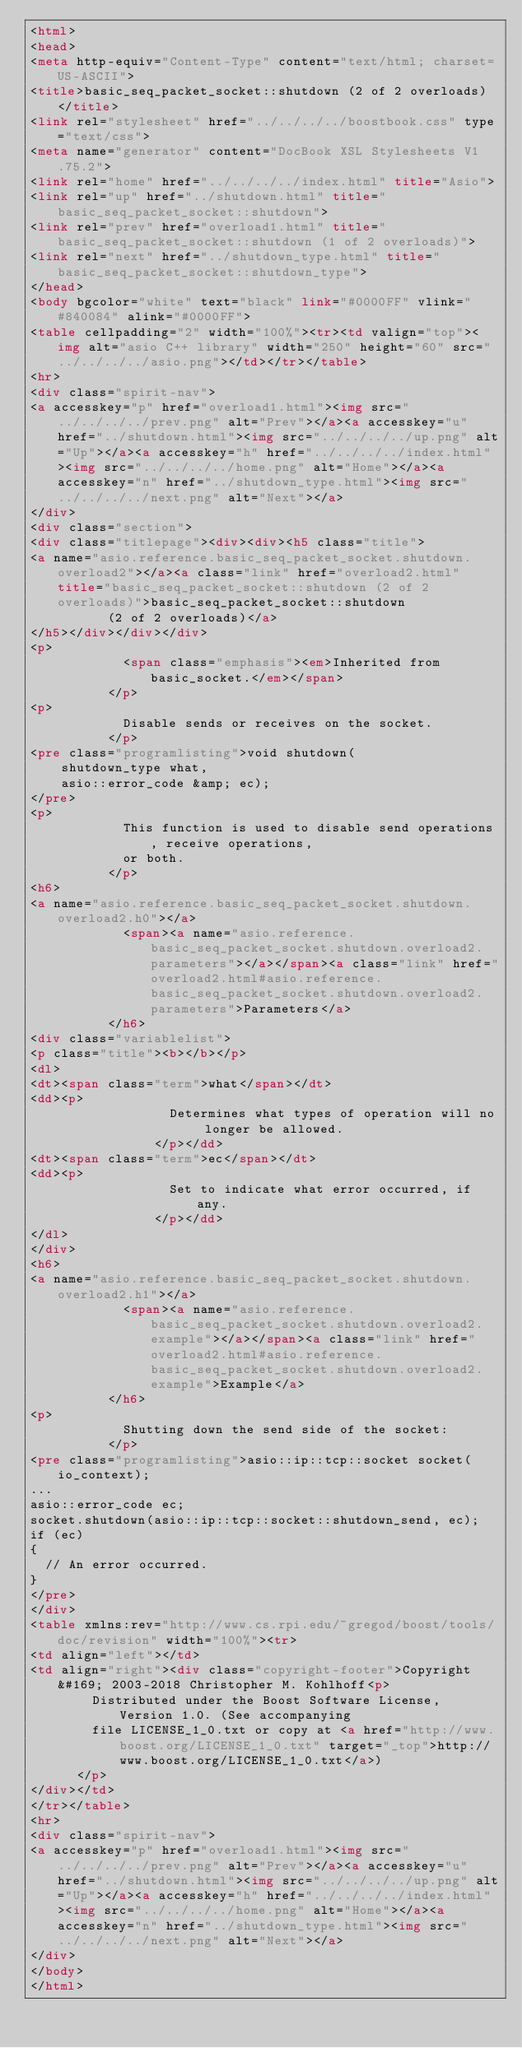<code> <loc_0><loc_0><loc_500><loc_500><_HTML_><html>
<head>
<meta http-equiv="Content-Type" content="text/html; charset=US-ASCII">
<title>basic_seq_packet_socket::shutdown (2 of 2 overloads)</title>
<link rel="stylesheet" href="../../../../boostbook.css" type="text/css">
<meta name="generator" content="DocBook XSL Stylesheets V1.75.2">
<link rel="home" href="../../../../index.html" title="Asio">
<link rel="up" href="../shutdown.html" title="basic_seq_packet_socket::shutdown">
<link rel="prev" href="overload1.html" title="basic_seq_packet_socket::shutdown (1 of 2 overloads)">
<link rel="next" href="../shutdown_type.html" title="basic_seq_packet_socket::shutdown_type">
</head>
<body bgcolor="white" text="black" link="#0000FF" vlink="#840084" alink="#0000FF">
<table cellpadding="2" width="100%"><tr><td valign="top"><img alt="asio C++ library" width="250" height="60" src="../../../../asio.png"></td></tr></table>
<hr>
<div class="spirit-nav">
<a accesskey="p" href="overload1.html"><img src="../../../../prev.png" alt="Prev"></a><a accesskey="u" href="../shutdown.html"><img src="../../../../up.png" alt="Up"></a><a accesskey="h" href="../../../../index.html"><img src="../../../../home.png" alt="Home"></a><a accesskey="n" href="../shutdown_type.html"><img src="../../../../next.png" alt="Next"></a>
</div>
<div class="section">
<div class="titlepage"><div><div><h5 class="title">
<a name="asio.reference.basic_seq_packet_socket.shutdown.overload2"></a><a class="link" href="overload2.html" title="basic_seq_packet_socket::shutdown (2 of 2 overloads)">basic_seq_packet_socket::shutdown
          (2 of 2 overloads)</a>
</h5></div></div></div>
<p>
            <span class="emphasis"><em>Inherited from basic_socket.</em></span>
          </p>
<p>
            Disable sends or receives on the socket.
          </p>
<pre class="programlisting">void shutdown(
    shutdown_type what,
    asio::error_code &amp; ec);
</pre>
<p>
            This function is used to disable send operations, receive operations,
            or both.
          </p>
<h6>
<a name="asio.reference.basic_seq_packet_socket.shutdown.overload2.h0"></a>
            <span><a name="asio.reference.basic_seq_packet_socket.shutdown.overload2.parameters"></a></span><a class="link" href="overload2.html#asio.reference.basic_seq_packet_socket.shutdown.overload2.parameters">Parameters</a>
          </h6>
<div class="variablelist">
<p class="title"><b></b></p>
<dl>
<dt><span class="term">what</span></dt>
<dd><p>
                  Determines what types of operation will no longer be allowed.
                </p></dd>
<dt><span class="term">ec</span></dt>
<dd><p>
                  Set to indicate what error occurred, if any.
                </p></dd>
</dl>
</div>
<h6>
<a name="asio.reference.basic_seq_packet_socket.shutdown.overload2.h1"></a>
            <span><a name="asio.reference.basic_seq_packet_socket.shutdown.overload2.example"></a></span><a class="link" href="overload2.html#asio.reference.basic_seq_packet_socket.shutdown.overload2.example">Example</a>
          </h6>
<p>
            Shutting down the send side of the socket:
          </p>
<pre class="programlisting">asio::ip::tcp::socket socket(io_context);
...
asio::error_code ec;
socket.shutdown(asio::ip::tcp::socket::shutdown_send, ec);
if (ec)
{
  // An error occurred.
}
</pre>
</div>
<table xmlns:rev="http://www.cs.rpi.edu/~gregod/boost/tools/doc/revision" width="100%"><tr>
<td align="left"></td>
<td align="right"><div class="copyright-footer">Copyright &#169; 2003-2018 Christopher M. Kohlhoff<p>
        Distributed under the Boost Software License, Version 1.0. (See accompanying
        file LICENSE_1_0.txt or copy at <a href="http://www.boost.org/LICENSE_1_0.txt" target="_top">http://www.boost.org/LICENSE_1_0.txt</a>)
      </p>
</div></td>
</tr></table>
<hr>
<div class="spirit-nav">
<a accesskey="p" href="overload1.html"><img src="../../../../prev.png" alt="Prev"></a><a accesskey="u" href="../shutdown.html"><img src="../../../../up.png" alt="Up"></a><a accesskey="h" href="../../../../index.html"><img src="../../../../home.png" alt="Home"></a><a accesskey="n" href="../shutdown_type.html"><img src="../../../../next.png" alt="Next"></a>
</div>
</body>
</html>
</code> 